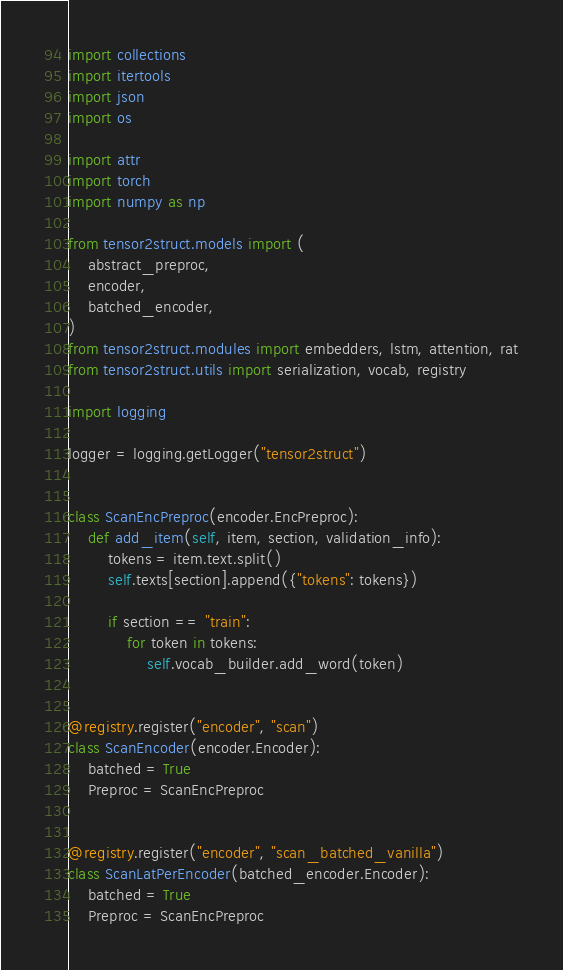Convert code to text. <code><loc_0><loc_0><loc_500><loc_500><_Python_>import collections
import itertools
import json
import os

import attr
import torch
import numpy as np

from tensor2struct.models import (
    abstract_preproc,
    encoder,
    batched_encoder,
)
from tensor2struct.modules import embedders, lstm, attention, rat
from tensor2struct.utils import serialization, vocab, registry

import logging

logger = logging.getLogger("tensor2struct")


class ScanEncPreproc(encoder.EncPreproc):
    def add_item(self, item, section, validation_info):
        tokens = item.text.split()
        self.texts[section].append({"tokens": tokens})

        if section == "train":
            for token in tokens:
                self.vocab_builder.add_word(token)


@registry.register("encoder", "scan")
class ScanEncoder(encoder.Encoder):
    batched = True
    Preproc = ScanEncPreproc


@registry.register("encoder", "scan_batched_vanilla")
class ScanLatPerEncoder(batched_encoder.Encoder):
    batched = True
    Preproc = ScanEncPreproc
</code> 